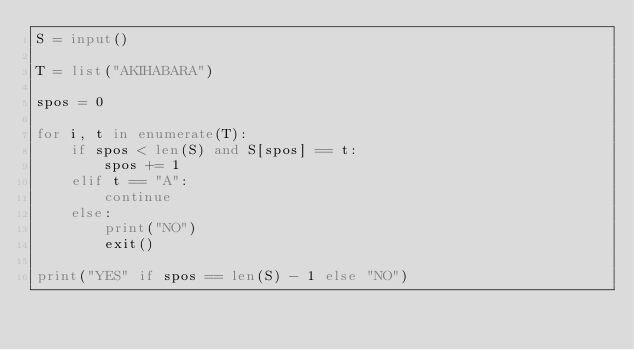<code> <loc_0><loc_0><loc_500><loc_500><_Python_>S = input()

T = list("AKIHABARA")

spos = 0

for i, t in enumerate(T):
    if spos < len(S) and S[spos] == t:
        spos += 1
    elif t == "A":
        continue
    else:
        print("NO")
        exit()

print("YES" if spos == len(S) - 1 else "NO")
</code> 